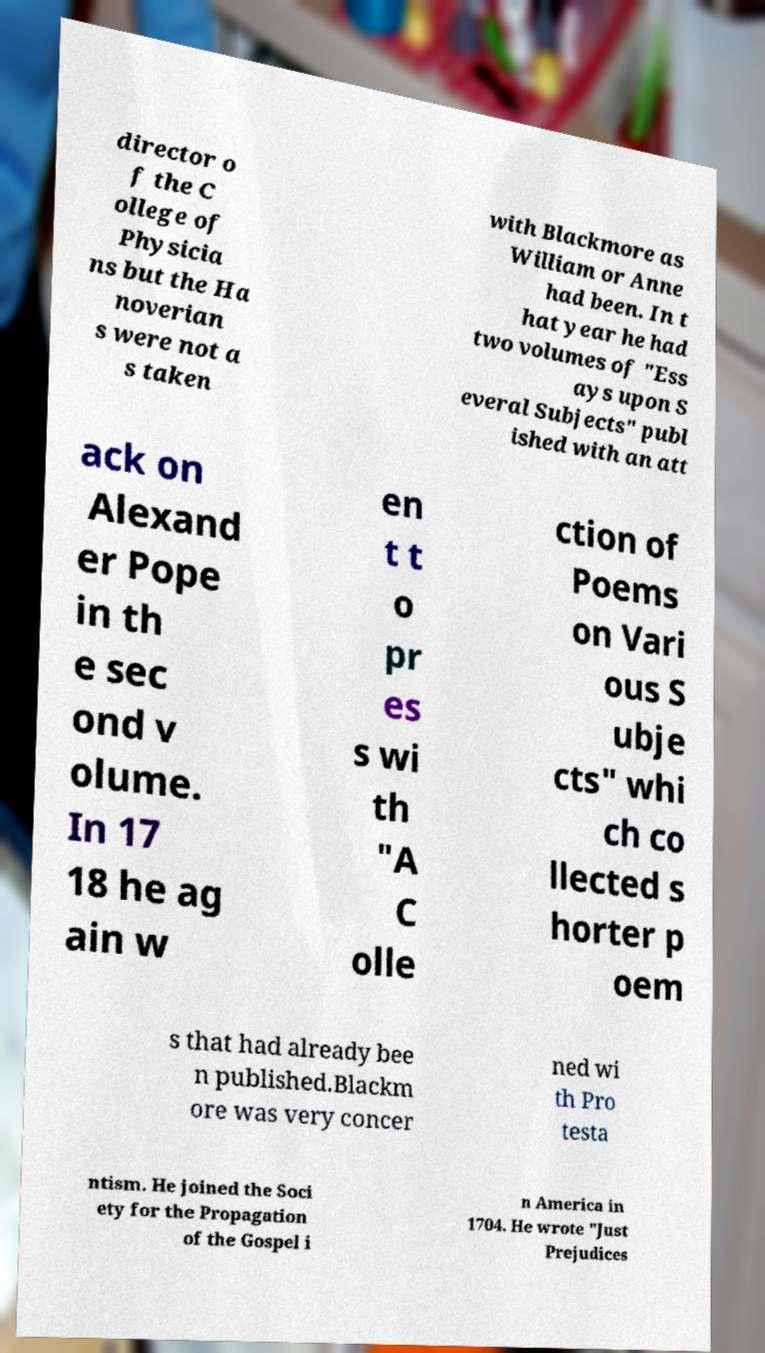For documentation purposes, I need the text within this image transcribed. Could you provide that? director o f the C ollege of Physicia ns but the Ha noverian s were not a s taken with Blackmore as William or Anne had been. In t hat year he had two volumes of "Ess ays upon S everal Subjects" publ ished with an att ack on Alexand er Pope in th e sec ond v olume. In 17 18 he ag ain w en t t o pr es s wi th "A C olle ction of Poems on Vari ous S ubje cts" whi ch co llected s horter p oem s that had already bee n published.Blackm ore was very concer ned wi th Pro testa ntism. He joined the Soci ety for the Propagation of the Gospel i n America in 1704. He wrote "Just Prejudices 